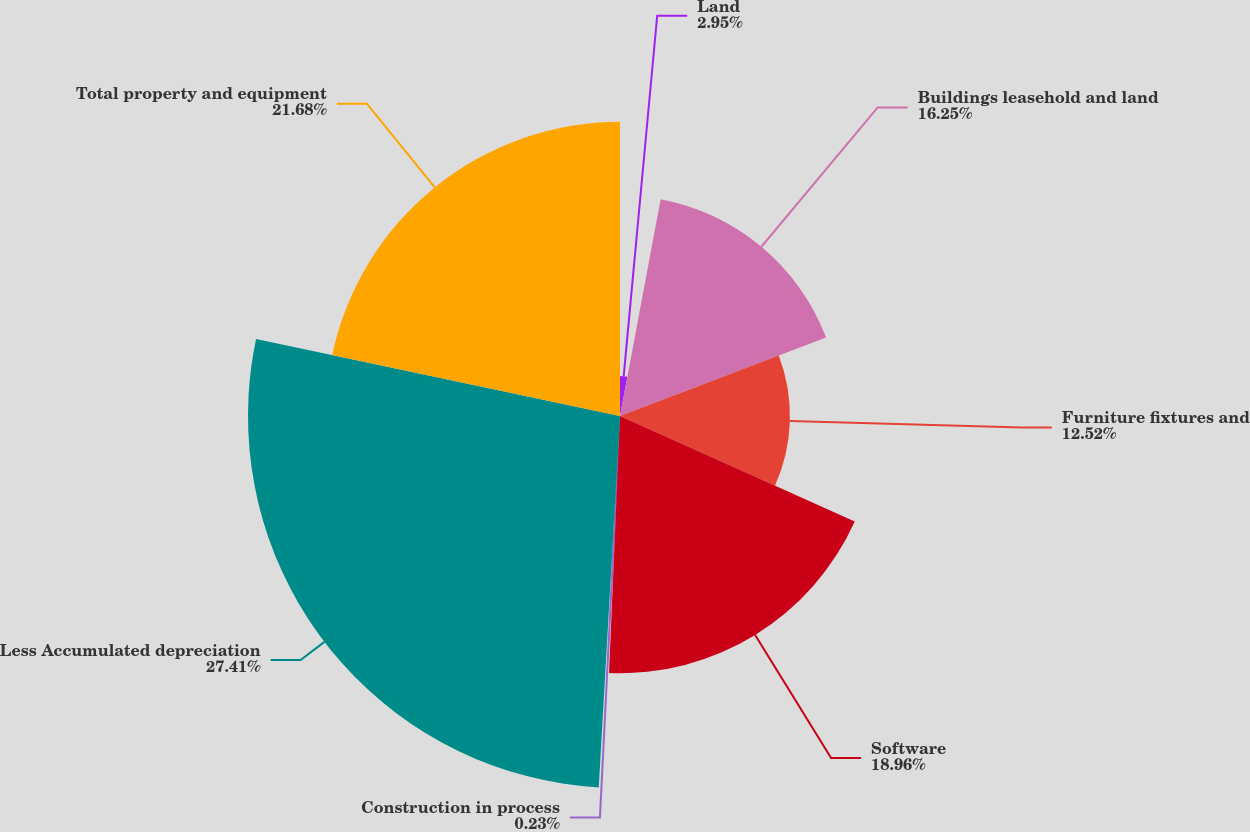<chart> <loc_0><loc_0><loc_500><loc_500><pie_chart><fcel>Land<fcel>Buildings leasehold and land<fcel>Furniture fixtures and<fcel>Software<fcel>Construction in process<fcel>Less Accumulated depreciation<fcel>Total property and equipment<nl><fcel>2.95%<fcel>16.25%<fcel>12.52%<fcel>18.96%<fcel>0.23%<fcel>27.41%<fcel>21.68%<nl></chart> 